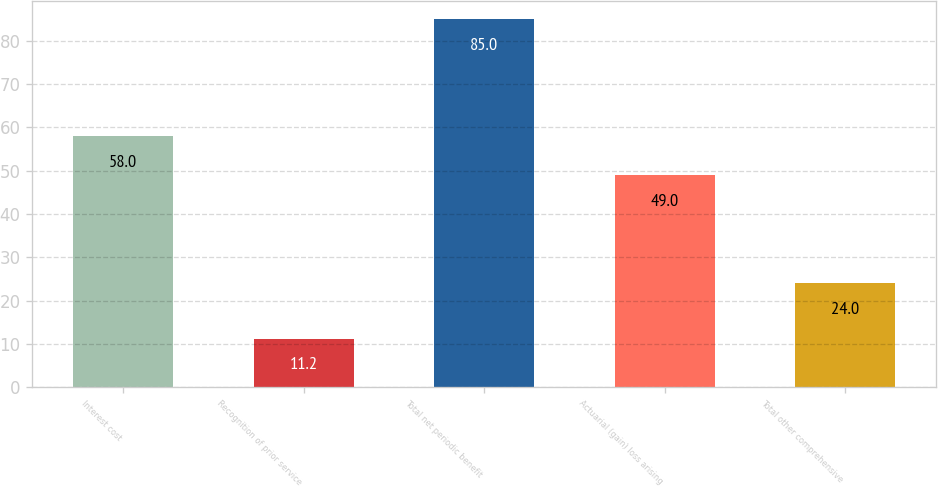Convert chart to OTSL. <chart><loc_0><loc_0><loc_500><loc_500><bar_chart><fcel>Interest cost<fcel>Recognition of prior service<fcel>Total net periodic benefit<fcel>Actuarial (gain) loss arising<fcel>Total other comprehensive<nl><fcel>58<fcel>11.2<fcel>85<fcel>49<fcel>24<nl></chart> 